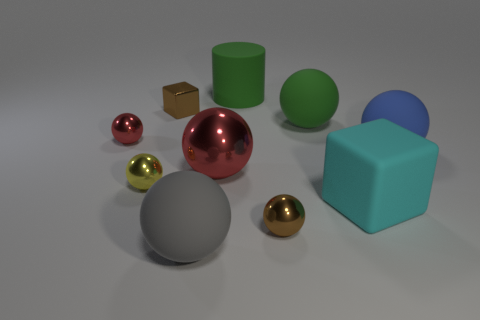There is a big thing that is both right of the large red metallic sphere and in front of the small yellow sphere; what is its material?
Give a very brief answer. Rubber. What is the shape of the metallic thing that is left of the yellow object?
Keep it short and to the point. Sphere. There is a tiny brown thing in front of the big green object that is in front of the big green matte cylinder; what shape is it?
Offer a terse response. Sphere. Are there any small brown metallic objects of the same shape as the large cyan object?
Give a very brief answer. Yes. What shape is the red metallic object that is the same size as the yellow ball?
Offer a terse response. Sphere. There is a red metallic thing that is to the left of the brown object that is behind the big blue rubber thing; are there any gray balls that are right of it?
Your answer should be very brief. Yes. Are there any red shiny cubes that have the same size as the blue matte ball?
Your answer should be compact. No. There is a brown metal thing in front of the matte block; what size is it?
Offer a very short reply. Small. The block that is on the left side of the big rubber sphere to the left of the large matte sphere that is behind the big blue matte ball is what color?
Give a very brief answer. Brown. What is the color of the rubber sphere that is behind the red object that is to the left of the big gray matte object?
Give a very brief answer. Green. 